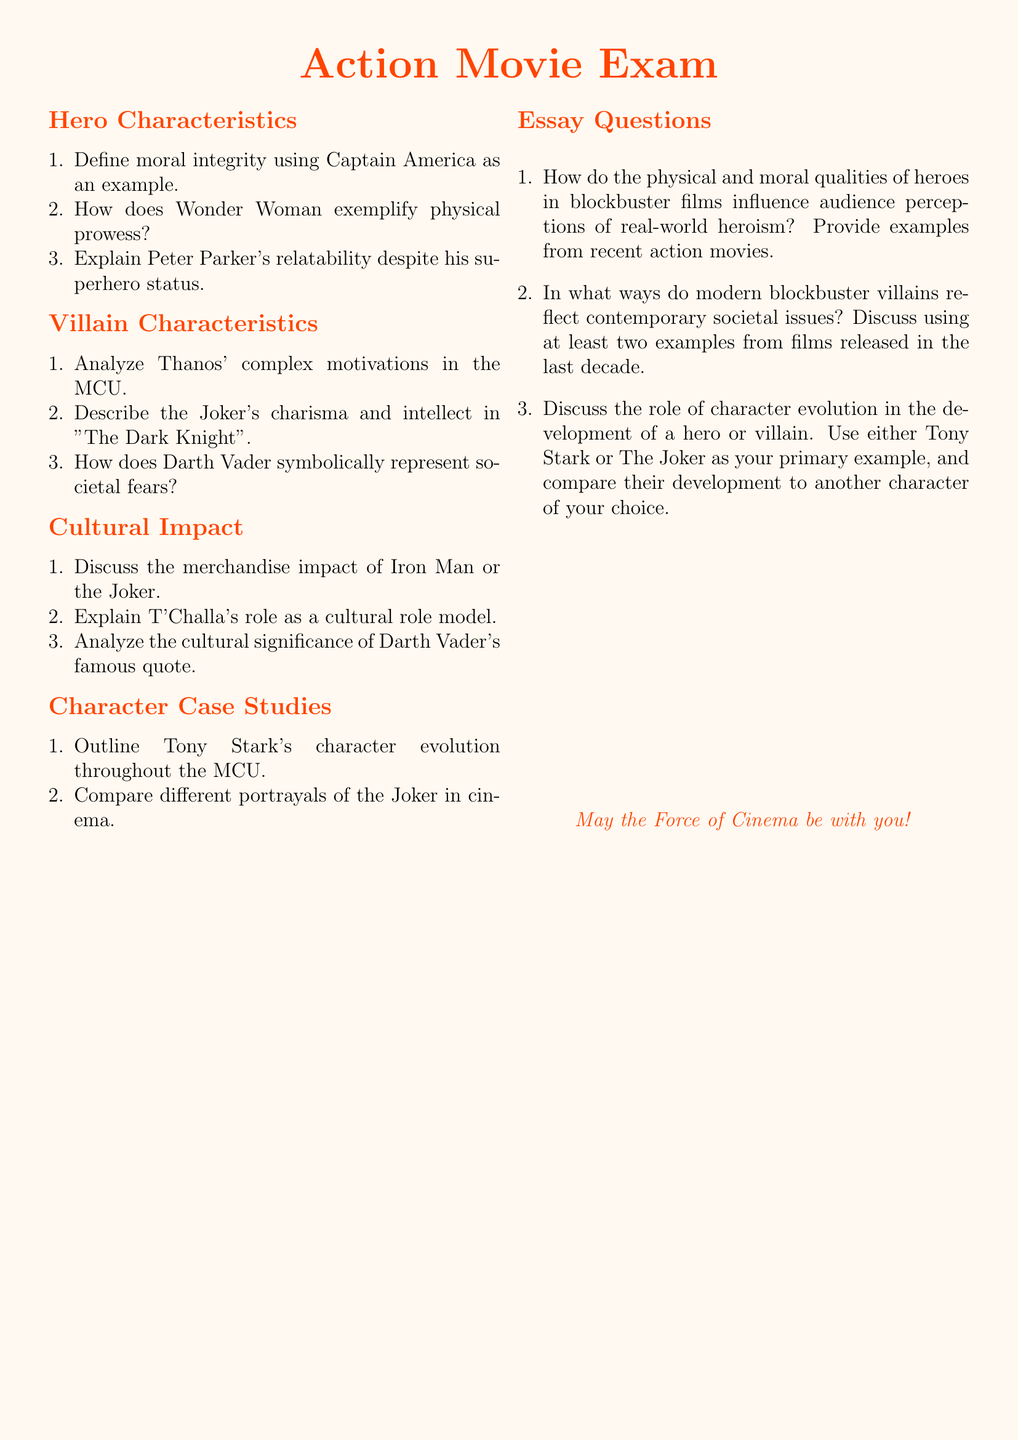What are the hero characteristics addressed in the document? The document lists specific hero characteristics such as moral integrity, physical prowess, and relatability.
Answer: moral integrity, physical prowess, relatability Who is used as an example of moral integrity? Captain America is specifically mentioned as an example of moral integrity in the hero characteristics.
Answer: Captain America What villain's complex motivations are analyzed in the document? Thanos' complex motivations are analyzed in the villain characteristics section.
Answer: Thanos Which character represents societal fears according to the document? Darth Vader is described as symbolically representing societal fears in the villain characteristics.
Answer: Darth Vader What impact is discussed concerning Iron Man or the Joker? The document discusses the merchandise impact of either Iron Man or the Joker under the cultural impact section.
Answer: merchandise impact What is the community role of T'Challa? T'Challa is indicated as a cultural role model in the cultural impact section of the document.
Answer: cultural role model How many case studies are outlined in the document? There are two character case studies outlined: Tony Stark's evolution and different portrayals of the Joker.
Answer: two What is the format of the questions in the document? The questions are provided in a structured format, including short answer and essay questions.
Answer: short answer and essay questions Which character's evolution is a focus of one of the essay questions? The essay questions specifically mention Tony Stark's character evolution for analysis.
Answer: Tony Stark 